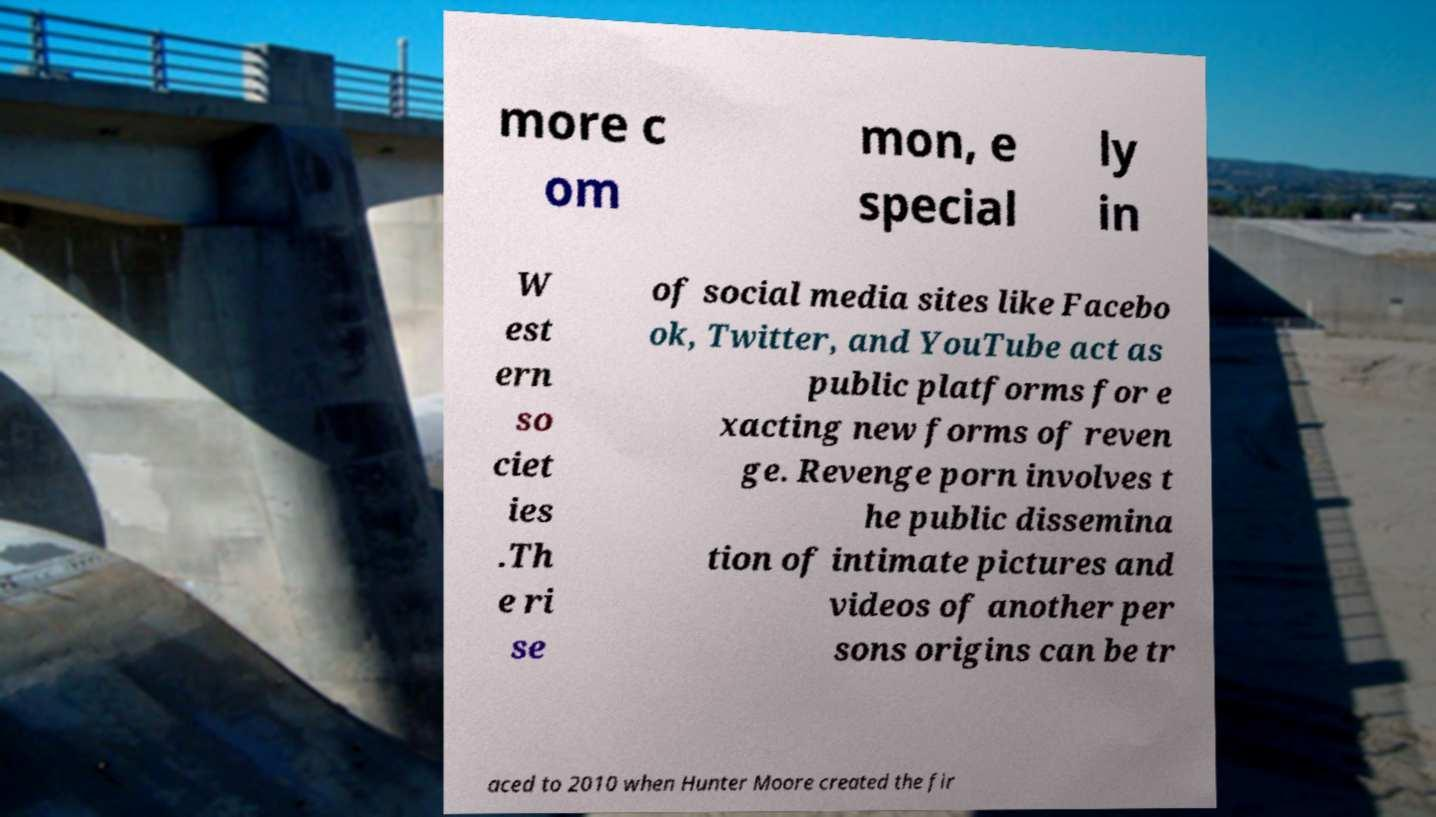Could you assist in decoding the text presented in this image and type it out clearly? more c om mon, e special ly in W est ern so ciet ies .Th e ri se of social media sites like Facebo ok, Twitter, and YouTube act as public platforms for e xacting new forms of reven ge. Revenge porn involves t he public dissemina tion of intimate pictures and videos of another per sons origins can be tr aced to 2010 when Hunter Moore created the fir 